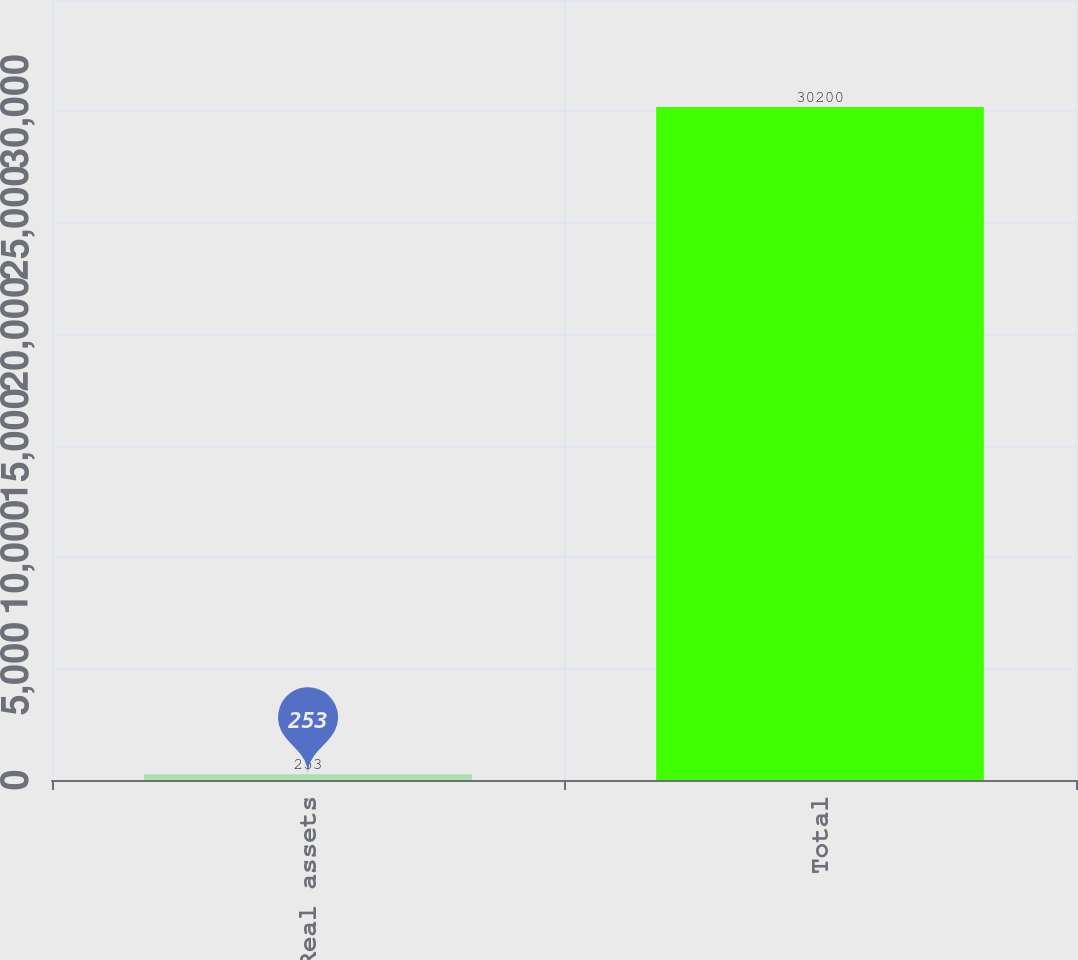Convert chart. <chart><loc_0><loc_0><loc_500><loc_500><bar_chart><fcel>Real assets<fcel>Total<nl><fcel>253<fcel>30200<nl></chart> 